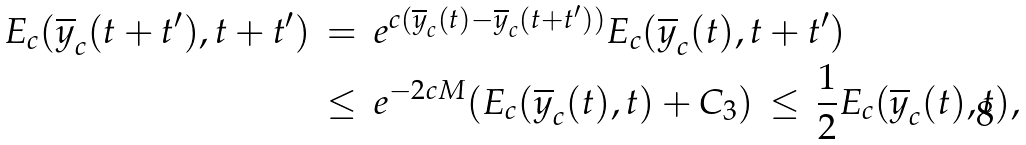<formula> <loc_0><loc_0><loc_500><loc_500>E _ { c } ( \overline { y } _ { c } ( t + t ^ { \prime } ) , t + t ^ { \prime } ) & \, = \, e ^ { c ( \overline { y } _ { c } ( t ) - \overline { y } _ { c } ( t + t ^ { \prime } ) ) } E _ { c } ( \overline { y } _ { c } ( t ) , t + t ^ { \prime } ) \\ & \, \leq \, e ^ { - 2 c M } ( E _ { c } ( \overline { y } _ { c } ( t ) , t ) + C _ { 3 } ) \, \leq \, { \frac { 1 } { 2 } } E _ { c } ( \overline { y } _ { c } ( t ) , t ) ,</formula> 